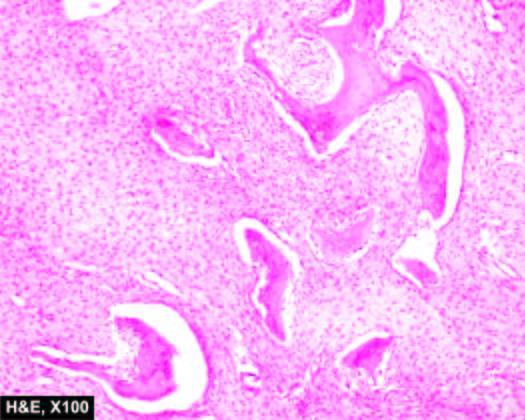do the bony trabeculae have fish-hook appearance surrounded by fibrous tissue?
Answer the question using a single word or phrase. Yes 